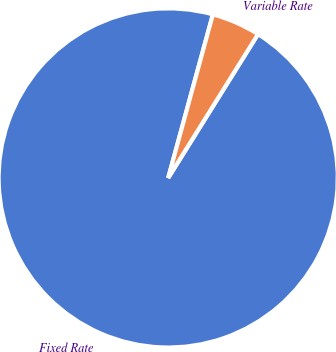Convert chart. <chart><loc_0><loc_0><loc_500><loc_500><pie_chart><fcel>Fixed Rate<fcel>Variable Rate<nl><fcel>95.36%<fcel>4.64%<nl></chart> 